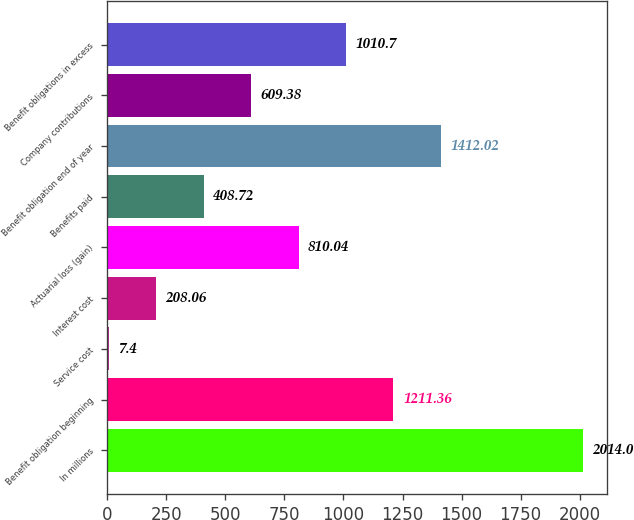Convert chart to OTSL. <chart><loc_0><loc_0><loc_500><loc_500><bar_chart><fcel>In millions<fcel>Benefit obligation beginning<fcel>Service cost<fcel>Interest cost<fcel>Actuarial loss (gain)<fcel>Benefits paid<fcel>Benefit obligation end of year<fcel>Company contributions<fcel>Benefit obligations in excess<nl><fcel>2014<fcel>1211.36<fcel>7.4<fcel>208.06<fcel>810.04<fcel>408.72<fcel>1412.02<fcel>609.38<fcel>1010.7<nl></chart> 